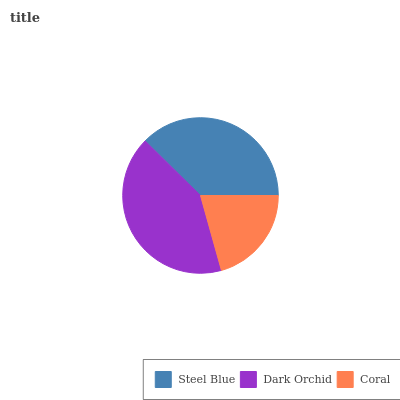Is Coral the minimum?
Answer yes or no. Yes. Is Dark Orchid the maximum?
Answer yes or no. Yes. Is Dark Orchid the minimum?
Answer yes or no. No. Is Coral the maximum?
Answer yes or no. No. Is Dark Orchid greater than Coral?
Answer yes or no. Yes. Is Coral less than Dark Orchid?
Answer yes or no. Yes. Is Coral greater than Dark Orchid?
Answer yes or no. No. Is Dark Orchid less than Coral?
Answer yes or no. No. Is Steel Blue the high median?
Answer yes or no. Yes. Is Steel Blue the low median?
Answer yes or no. Yes. Is Dark Orchid the high median?
Answer yes or no. No. Is Dark Orchid the low median?
Answer yes or no. No. 